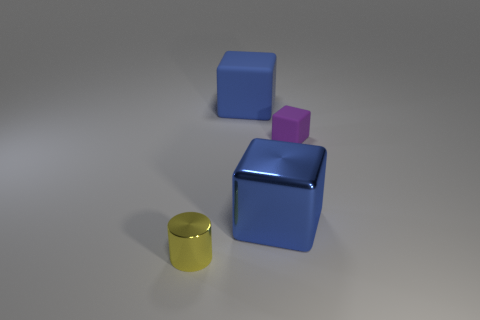Add 2 yellow cylinders. How many objects exist? 6 Subtract all cylinders. How many objects are left? 3 Add 2 small green metallic things. How many small green metallic things exist? 2 Subtract 0 yellow blocks. How many objects are left? 4 Subtract all small purple rubber cylinders. Subtract all blue objects. How many objects are left? 2 Add 3 tiny yellow cylinders. How many tiny yellow cylinders are left? 4 